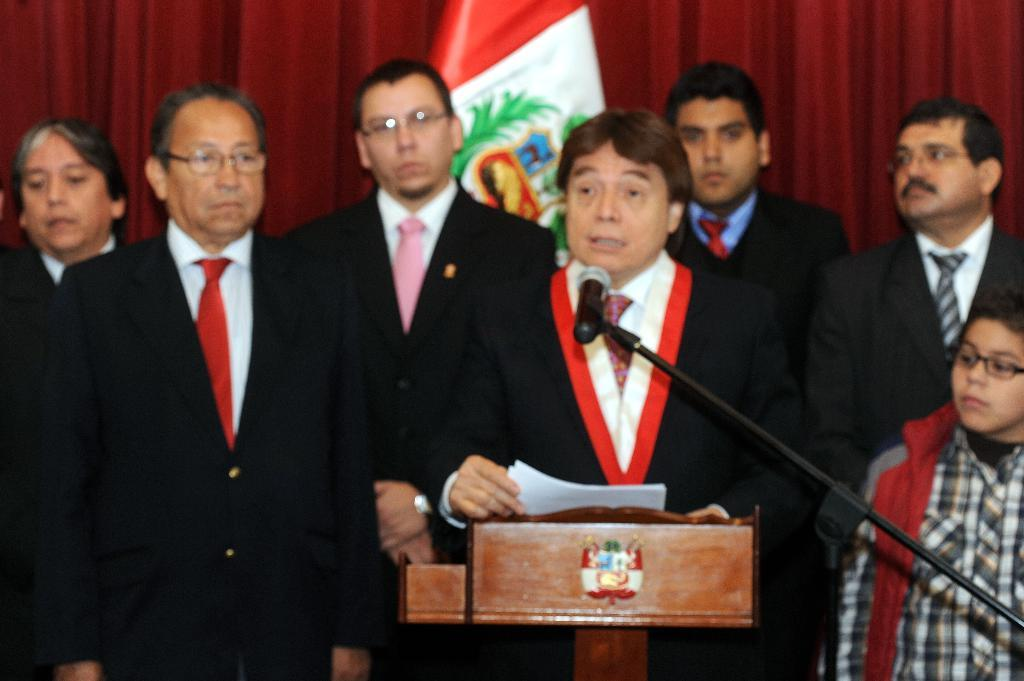How many men are in the image? There is a group of men in the image. What are the men doing in the image? The men are standing in the image. What color clothes are the men wearing? The men are wearing black clothes. What object can be seen in the image that is typically used for speeches or presentations? There is a podium in the image. What object can be seen in the image that is used for amplifying sound? There is a microphone in the image. What type of background can be seen in the image? There are curtains in the background of the image. What type of canvas is the writer using to create a painting in the image? There is no writer or canvas present in the image; it features a group of men standing with a podium and microphone. How does the sleet affect the men in the image? There is no mention of sleet in the image; the weather appears to be clear, as indicated by the presence of a podium and microphone. 